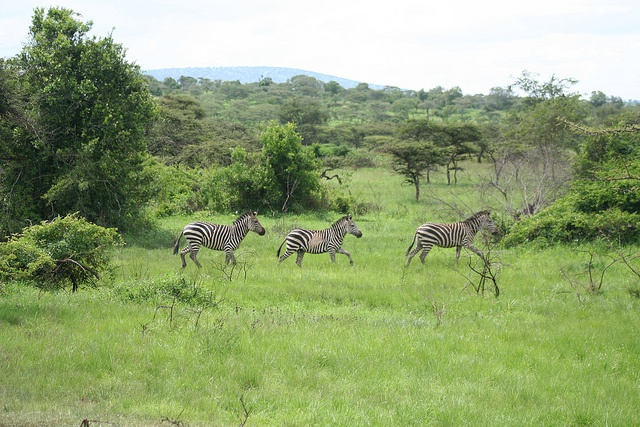Describe the objects in this image and their specific colors. I can see zebra in white, gray, olive, darkgray, and black tones, zebra in white, gray, black, darkgray, and olive tones, and zebra in white, gray, darkgray, black, and olive tones in this image. 